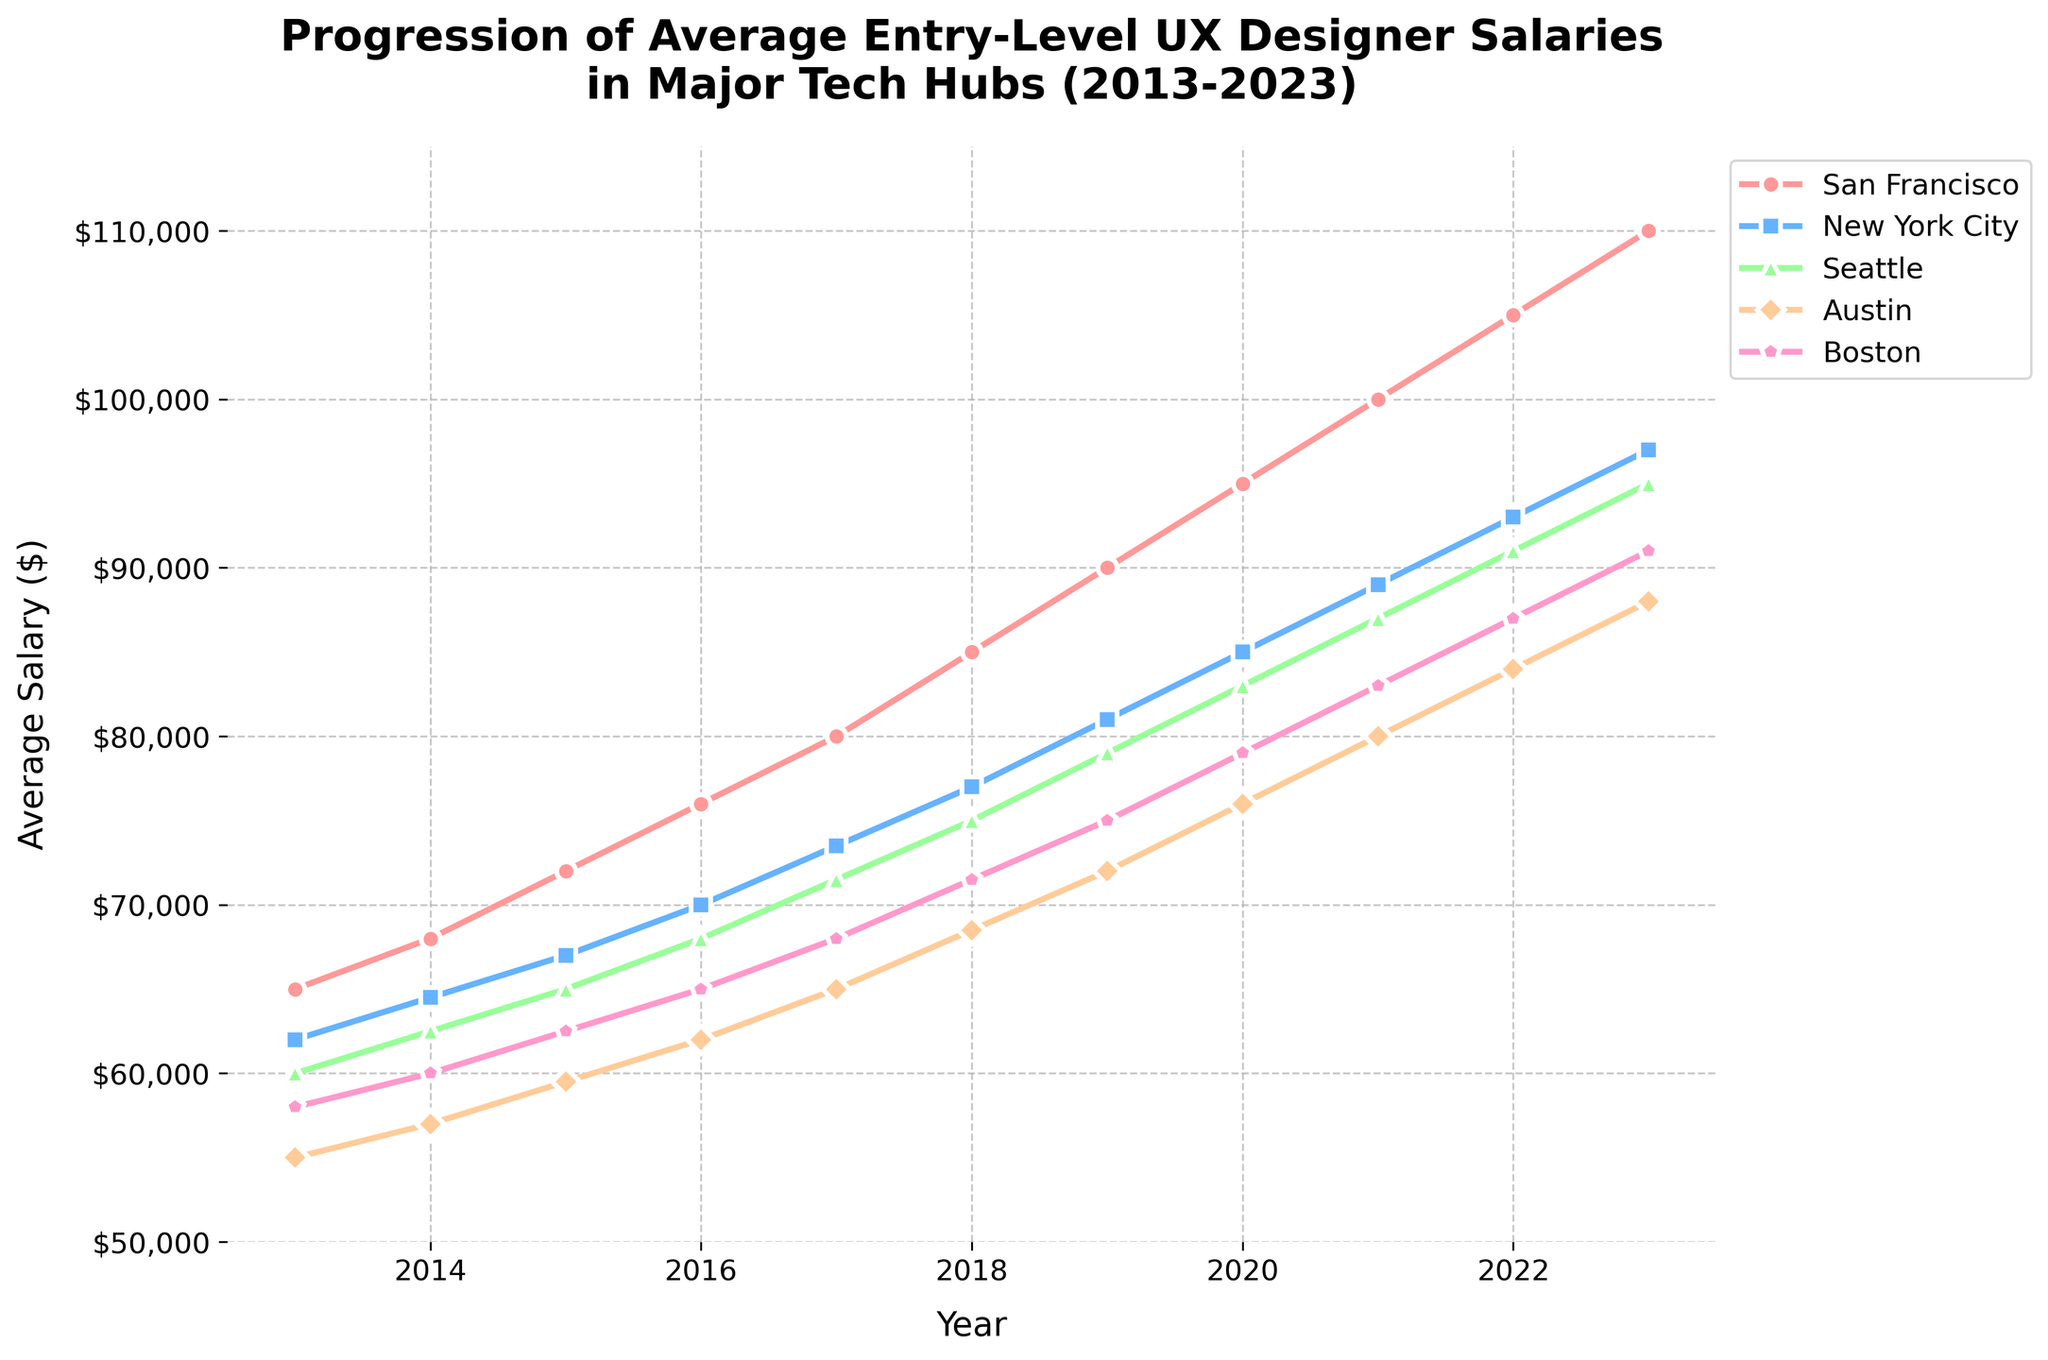Which city had the highest average salary for entry-level UX designers in 2023? Look at the data points for the year 2023 across all cities. The highest value is in San Francisco at $110,000.
Answer: San Francisco How much did the average salary for entry-level UX designers in New York City increase from 2013 to 2023? Check the values for New York City for the years 2013 and 2023. The increase is calculated as $97,000 (2023) - $62,000 (2013) = $35,000.
Answer: $35,000 Which city had the smallest growth in average salary over the decade? Calculate the difference between 2023 and 2013 values for each city. Austin's growth is the smallest: $88,000 (2023) - $55,000 (2013) = $33,000.
Answer: Austin In which year did Seattle's average salary for entry-level UX designers surpass $75,000? Look at Seattle's salary progression and identify the first year where the value exceeds $75,000. It is in 2018 with $75,000.
Answer: 2018 On average, how much did the average salary for entry-level UX designers in Boston increase each year from 2013 to 2023? Calculate the total increase for Boston as $91,000 (2023) - $58,000 (2013) = $33,000. There are 10 intervals between 2013 and 2023, so the average annual increase is $33,000 / 10 years = $3,300.
Answer: $3,300 Which two cities had the closest average salaries in 2020? Compare the values for 2020. Seattle and Boston had very close salaries: $83,000 (Seattle) and $79,000 (Boston), a difference of $4,000.
Answer: Seattle and Boston Which city experienced the largest increase in average salaries between 2017 and 2018? Calculate the increase for each city between 2017 and 2018 and identify the highest increase: San Francisco $85,000 - $80,000 = $5,000.
Answer: San Francisco During which year did Austin's average salary first exceed $70,000? Check the values for Austin and find when it first surpasses $70,000. This happened in the year 2021 with a salary of $80,000.
Answer: 2021 